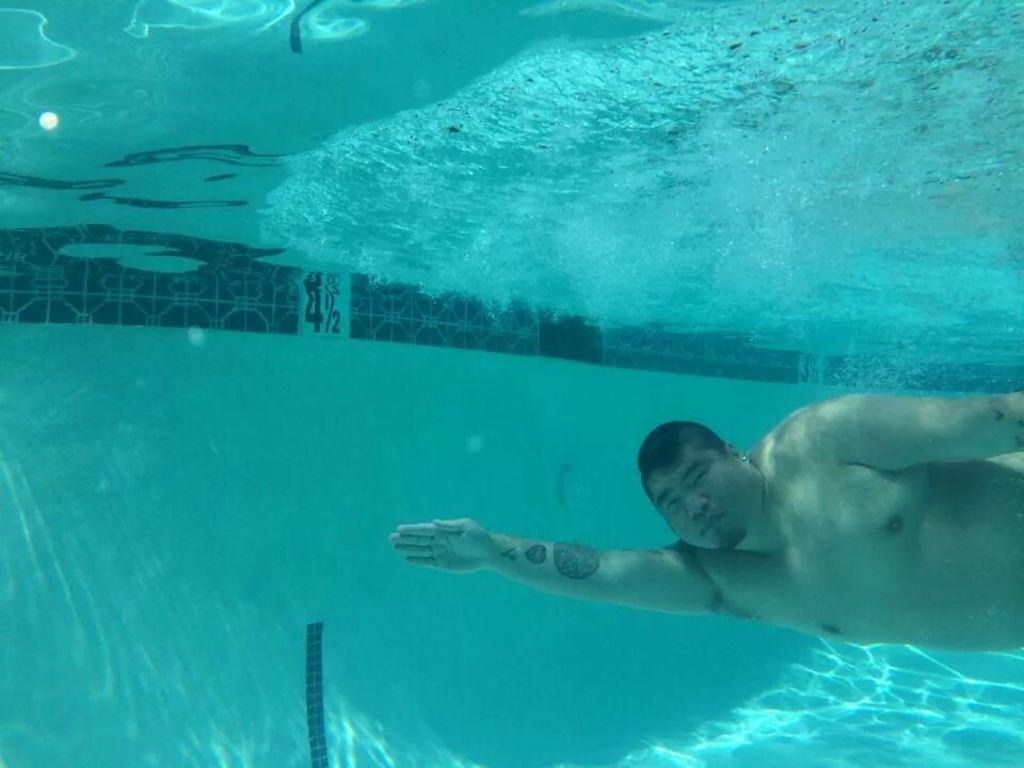Who or what is present in the image? There is a person in the image. Can you describe the location of the person in the image? The person is underwater. What can be seen in the background of the image? There is something written in the background of the image. Reasoning: Let' Let's think step by step in order to produce the conversation. We start by identifying the main subject in the image, which is the person. Then, we describe the person's location, which is underwater. Finally, we mention the presence of writing in the background of the image. Each question is designed to elicit a specific detail about the image that is known from the provided facts. Absurd Question/Answer: What type of vessel is the person traveling in, and how many passengers are on board? There is no vessel present in the image, and no information about passengers is available. 